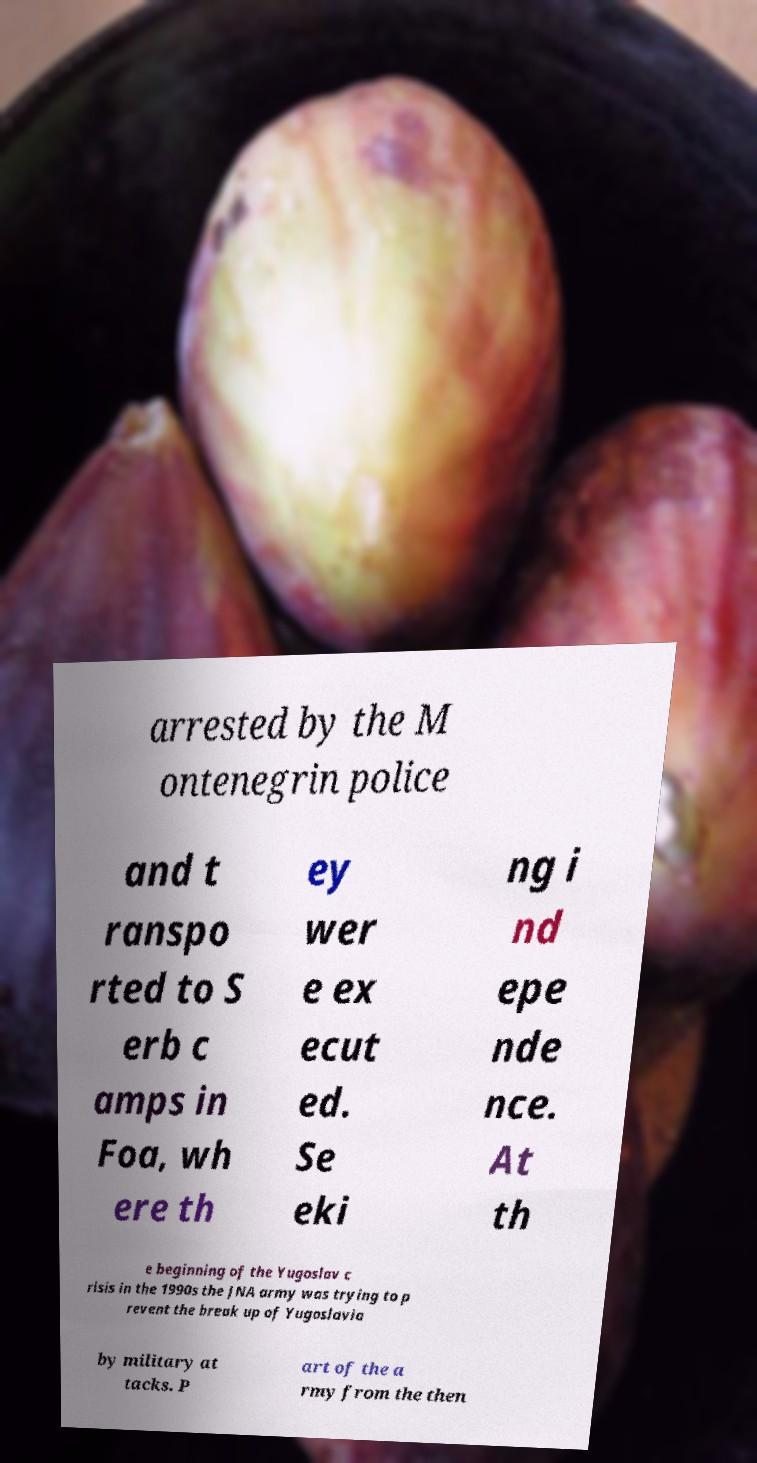I need the written content from this picture converted into text. Can you do that? arrested by the M ontenegrin police and t ranspo rted to S erb c amps in Foa, wh ere th ey wer e ex ecut ed. Se eki ng i nd epe nde nce. At th e beginning of the Yugoslav c risis in the 1990s the JNA army was trying to p revent the break up of Yugoslavia by military at tacks. P art of the a rmy from the then 